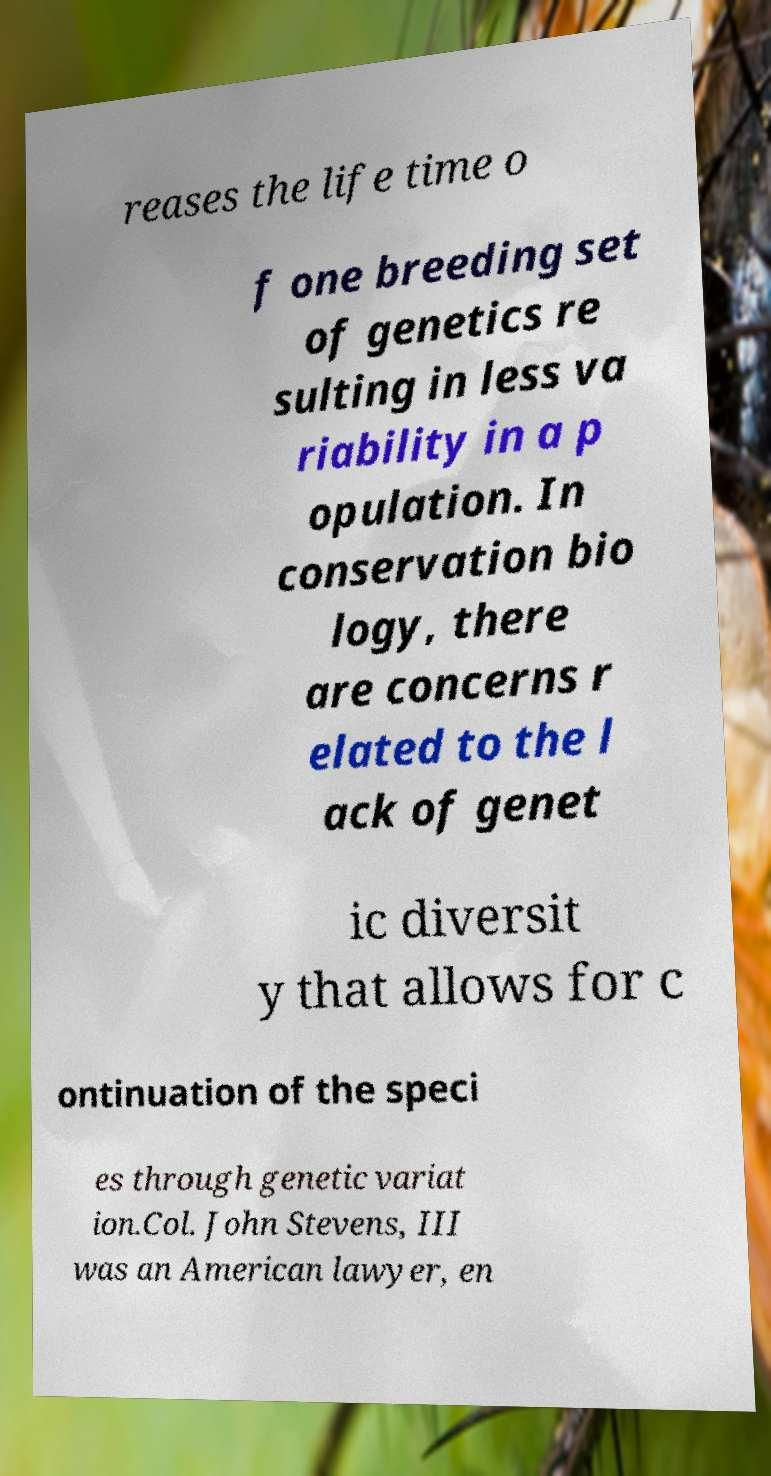Please identify and transcribe the text found in this image. reases the life time o f one breeding set of genetics re sulting in less va riability in a p opulation. In conservation bio logy, there are concerns r elated to the l ack of genet ic diversit y that allows for c ontinuation of the speci es through genetic variat ion.Col. John Stevens, III was an American lawyer, en 